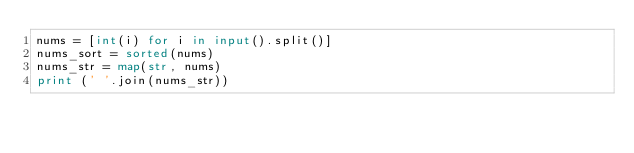Convert code to text. <code><loc_0><loc_0><loc_500><loc_500><_Python_>nums = [int(i) for i in input().split()]
nums_sort = sorted(nums)
nums_str = map(str, nums)
print (' '.join(nums_str))</code> 